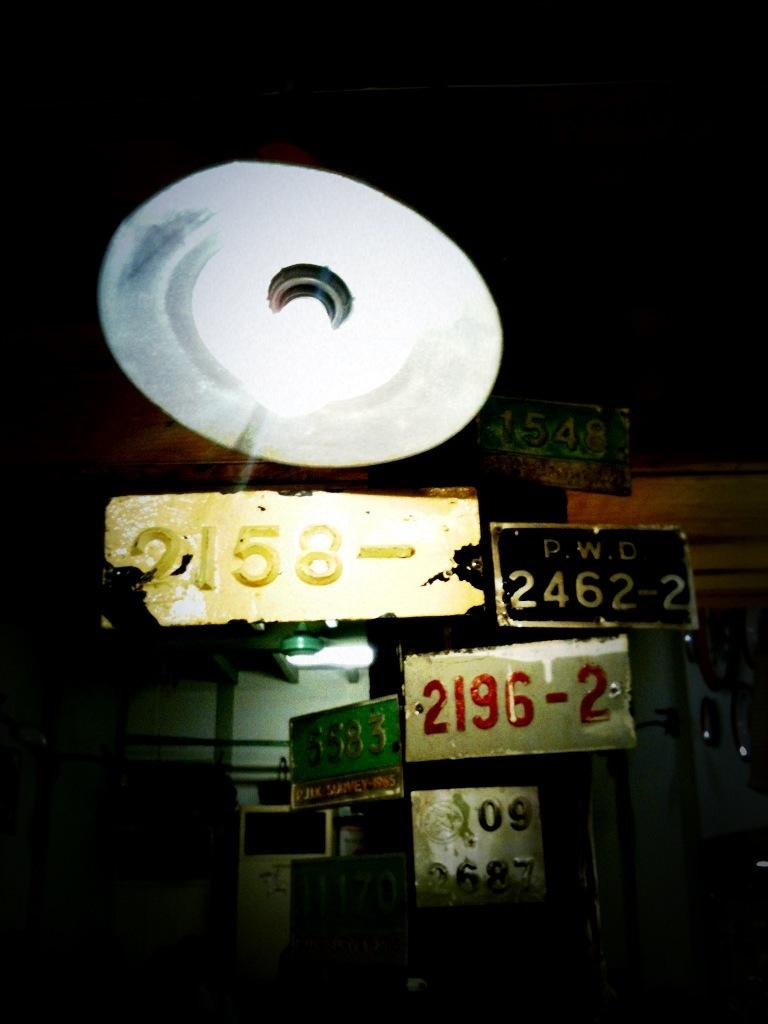<image>
Offer a succinct explanation of the picture presented. the numbers 2462 that is on a sign 